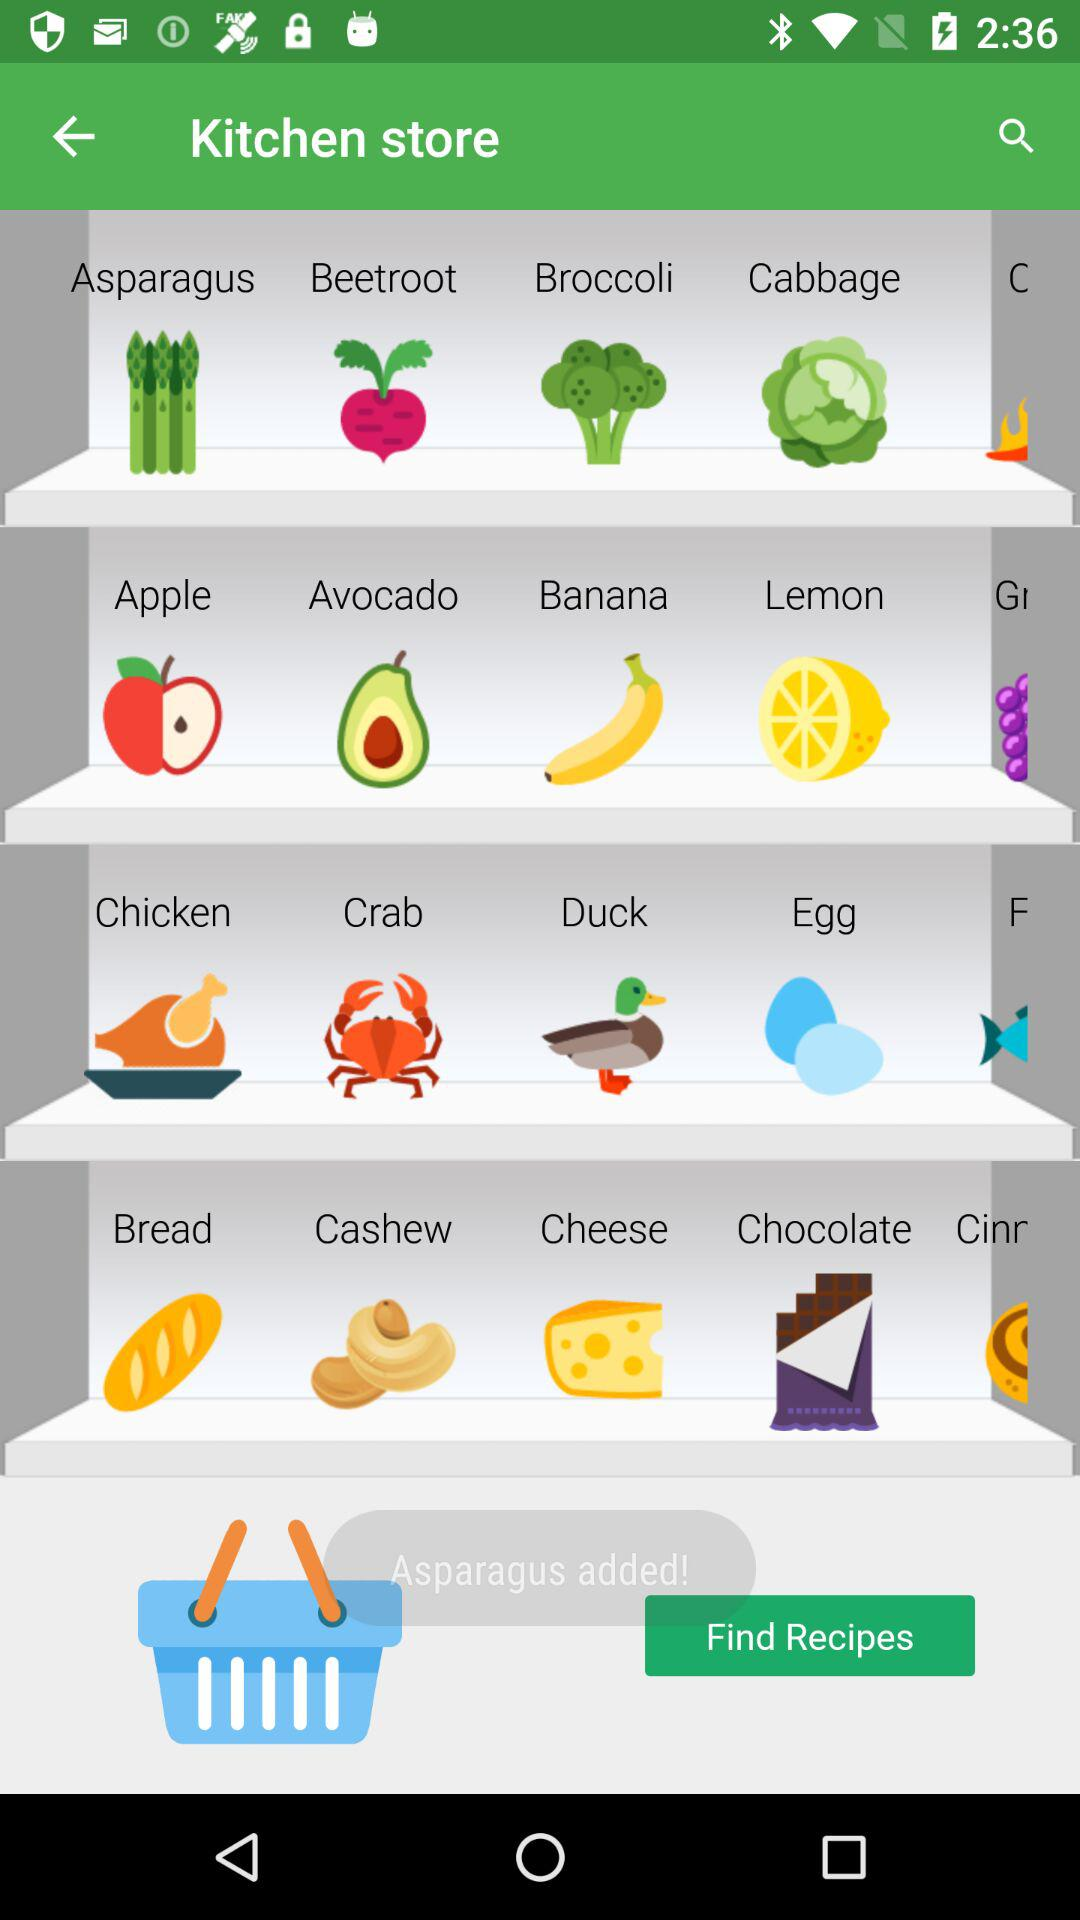How many items are in the cart?
When the provided information is insufficient, respond with <no answer>. <no answer> 